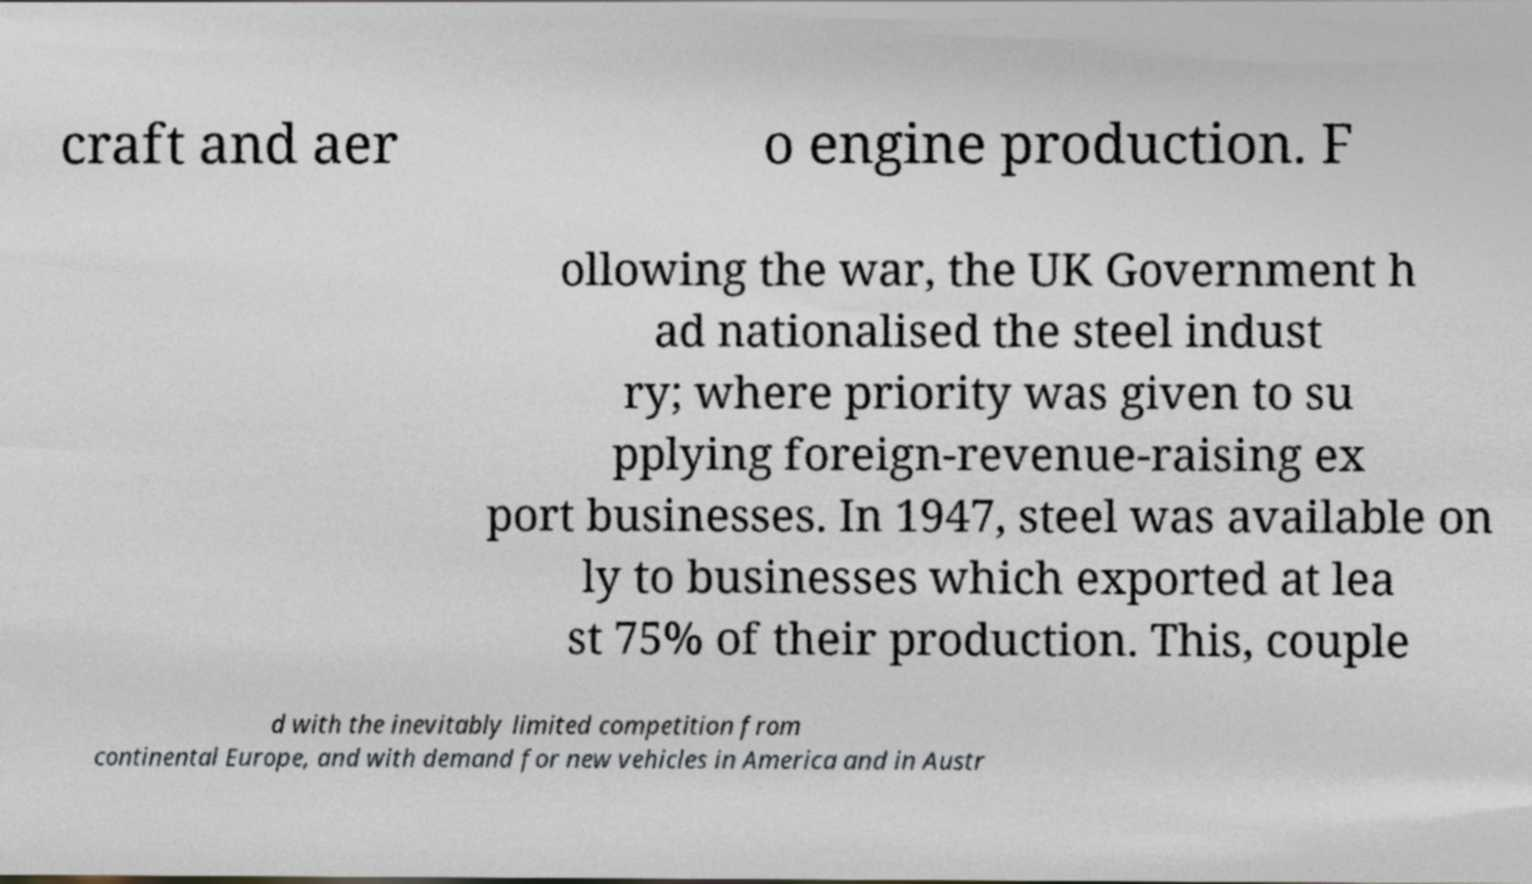For documentation purposes, I need the text within this image transcribed. Could you provide that? craft and aer o engine production. F ollowing the war, the UK Government h ad nationalised the steel indust ry; where priority was given to su pplying foreign-revenue-raising ex port businesses. In 1947, steel was available on ly to businesses which exported at lea st 75% of their production. This, couple d with the inevitably limited competition from continental Europe, and with demand for new vehicles in America and in Austr 